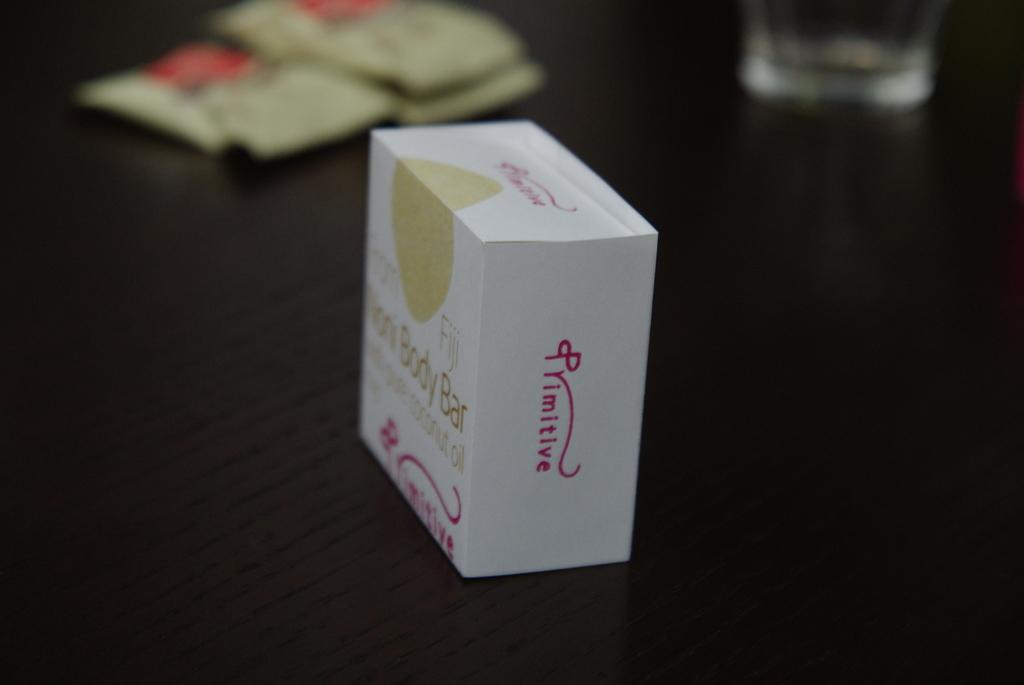<image>
Offer a succinct explanation of the picture presented. The body bar in the box contains coconut oil. 